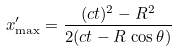<formula> <loc_0><loc_0><loc_500><loc_500>x ^ { \prime } _ { \max } = \frac { ( c t ) ^ { 2 } - R ^ { 2 } } { 2 ( c t - R \, \cos \theta ) }</formula> 